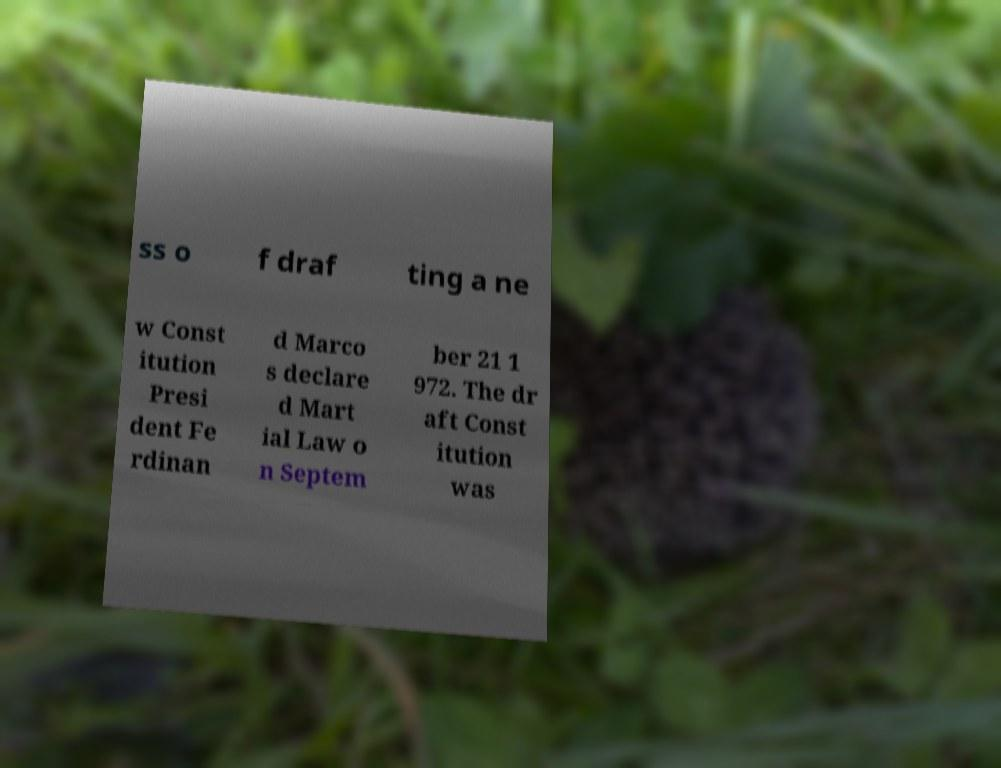I need the written content from this picture converted into text. Can you do that? ss o f draf ting a ne w Const itution Presi dent Fe rdinan d Marco s declare d Mart ial Law o n Septem ber 21 1 972. The dr aft Const itution was 